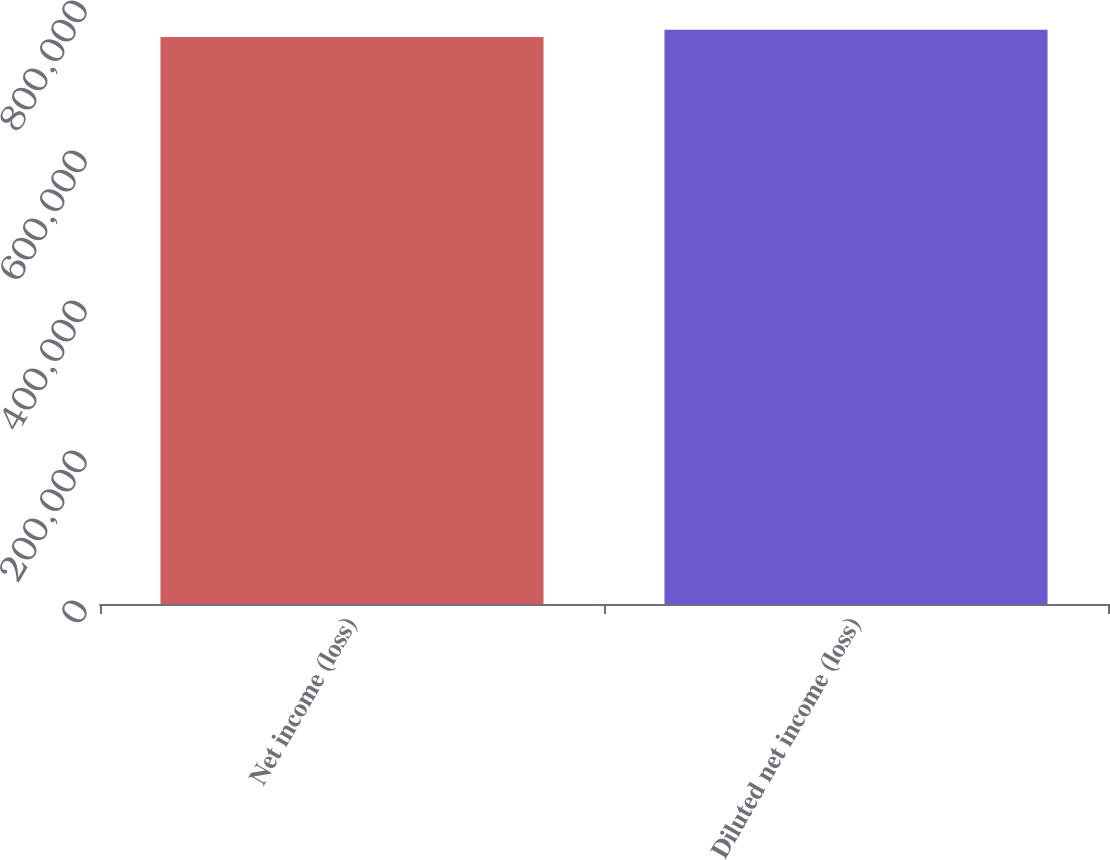<chart> <loc_0><loc_0><loc_500><loc_500><bar_chart><fcel>Net income (loss)<fcel>Diluted net income (loss)<nl><fcel>756054<fcel>765571<nl></chart> 